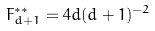<formula> <loc_0><loc_0><loc_500><loc_500>F ^ { * * } _ { d + 1 } = 4 d ( d + 1 ) ^ { - 2 }</formula> 